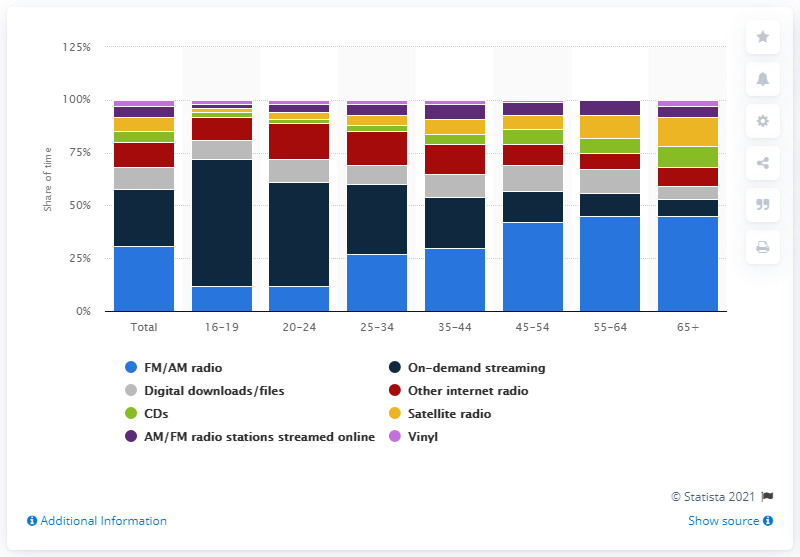Give some essential details in this illustration. According to data, individuals between the ages of 35 and 44 spent approximately 24% of their time listening to music. 